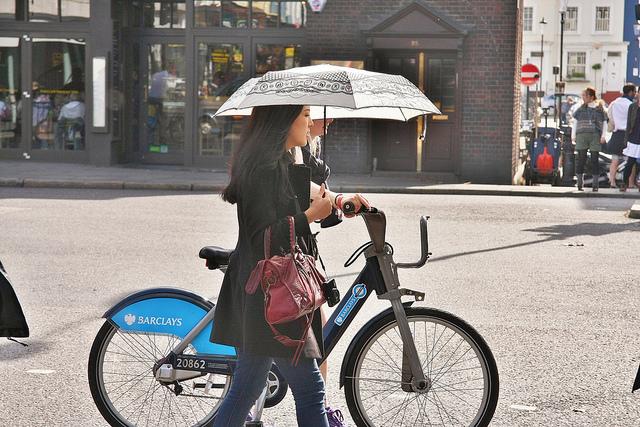Why is the woman holding an umbrella?
Write a very short answer. Sun protection. How long is the women's coat?
Quick response, please. Mid length. Is this bicycle owned or rented?
Quick response, please. Rented. What color is the umbrella?
Concise answer only. White and black. 